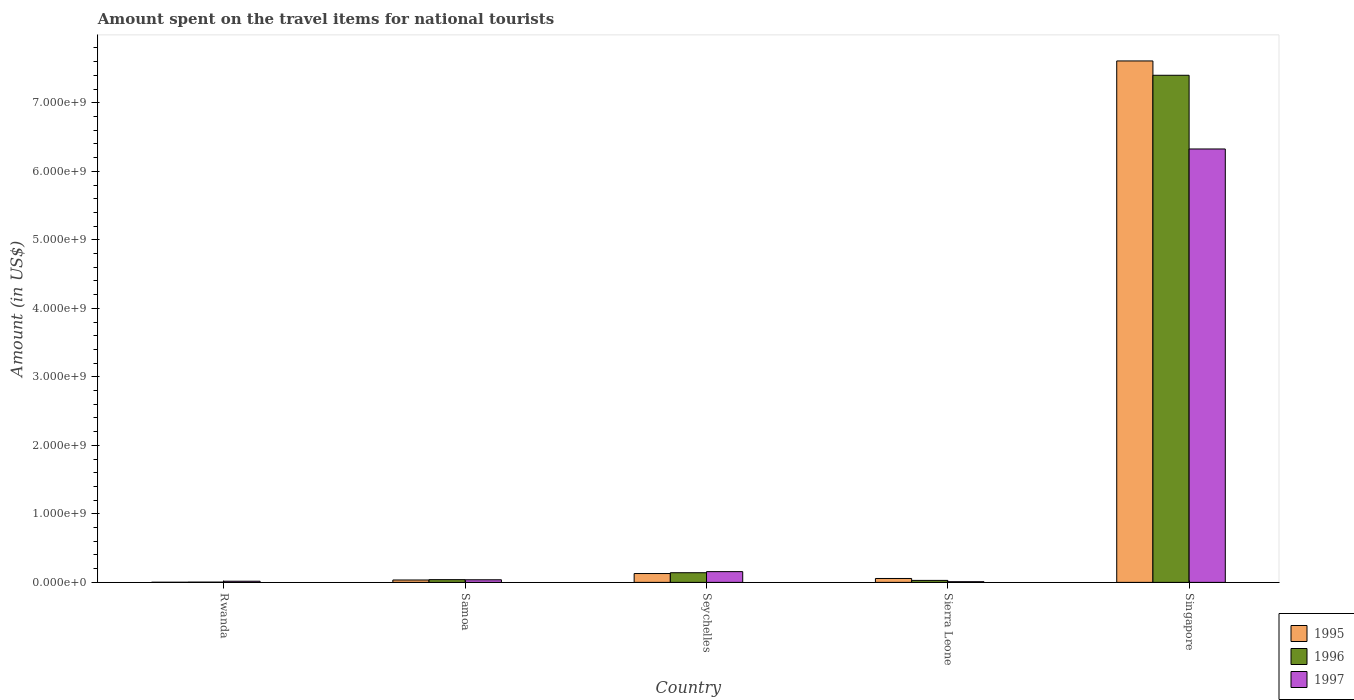How many different coloured bars are there?
Your answer should be very brief. 3. How many groups of bars are there?
Make the answer very short. 5. What is the label of the 4th group of bars from the left?
Provide a short and direct response. Sierra Leone. In how many cases, is the number of bars for a given country not equal to the number of legend labels?
Your response must be concise. 0. What is the amount spent on the travel items for national tourists in 1996 in Sierra Leone?
Make the answer very short. 2.90e+07. Across all countries, what is the maximum amount spent on the travel items for national tourists in 1995?
Your response must be concise. 7.61e+09. In which country was the amount spent on the travel items for national tourists in 1996 maximum?
Ensure brevity in your answer.  Singapore. In which country was the amount spent on the travel items for national tourists in 1996 minimum?
Your response must be concise. Rwanda. What is the total amount spent on the travel items for national tourists in 1995 in the graph?
Your answer should be compact. 7.83e+09. What is the difference between the amount spent on the travel items for national tourists in 1997 in Rwanda and that in Samoa?
Offer a terse response. -2.10e+07. What is the difference between the amount spent on the travel items for national tourists in 1995 in Seychelles and the amount spent on the travel items for national tourists in 1997 in Samoa?
Keep it short and to the point. 9.10e+07. What is the average amount spent on the travel items for national tourists in 1997 per country?
Offer a very short reply. 1.31e+09. What is the difference between the amount spent on the travel items for national tourists of/in 1996 and amount spent on the travel items for national tourists of/in 1995 in Samoa?
Provide a short and direct response. 5.00e+06. What is the ratio of the amount spent on the travel items for national tourists in 1995 in Samoa to that in Sierra Leone?
Ensure brevity in your answer.  0.61. Is the amount spent on the travel items for national tourists in 1995 in Seychelles less than that in Sierra Leone?
Offer a very short reply. No. What is the difference between the highest and the second highest amount spent on the travel items for national tourists in 1996?
Your response must be concise. 7.36e+09. What is the difference between the highest and the lowest amount spent on the travel items for national tourists in 1997?
Keep it short and to the point. 6.32e+09. What does the 2nd bar from the left in Seychelles represents?
Your answer should be compact. 1996. What does the 3rd bar from the right in Seychelles represents?
Ensure brevity in your answer.  1995. Is it the case that in every country, the sum of the amount spent on the travel items for national tourists in 1997 and amount spent on the travel items for national tourists in 1995 is greater than the amount spent on the travel items for national tourists in 1996?
Offer a very short reply. Yes. How many countries are there in the graph?
Your answer should be very brief. 5. What is the difference between two consecutive major ticks on the Y-axis?
Provide a short and direct response. 1.00e+09. Are the values on the major ticks of Y-axis written in scientific E-notation?
Provide a short and direct response. Yes. Does the graph contain any zero values?
Your answer should be compact. No. How many legend labels are there?
Make the answer very short. 3. How are the legend labels stacked?
Your response must be concise. Vertical. What is the title of the graph?
Offer a very short reply. Amount spent on the travel items for national tourists. What is the label or title of the X-axis?
Ensure brevity in your answer.  Country. What is the label or title of the Y-axis?
Your answer should be very brief. Amount (in US$). What is the Amount (in US$) in 1997 in Rwanda?
Your answer should be compact. 1.70e+07. What is the Amount (in US$) of 1995 in Samoa?
Your answer should be very brief. 3.50e+07. What is the Amount (in US$) in 1996 in Samoa?
Your answer should be compact. 4.00e+07. What is the Amount (in US$) of 1997 in Samoa?
Offer a terse response. 3.80e+07. What is the Amount (in US$) in 1995 in Seychelles?
Offer a very short reply. 1.29e+08. What is the Amount (in US$) in 1996 in Seychelles?
Your response must be concise. 1.41e+08. What is the Amount (in US$) in 1997 in Seychelles?
Ensure brevity in your answer.  1.57e+08. What is the Amount (in US$) of 1995 in Sierra Leone?
Offer a very short reply. 5.70e+07. What is the Amount (in US$) of 1996 in Sierra Leone?
Offer a terse response. 2.90e+07. What is the Amount (in US$) of 1995 in Singapore?
Provide a succinct answer. 7.61e+09. What is the Amount (in US$) of 1996 in Singapore?
Offer a terse response. 7.40e+09. What is the Amount (in US$) in 1997 in Singapore?
Keep it short and to the point. 6.33e+09. Across all countries, what is the maximum Amount (in US$) in 1995?
Your answer should be very brief. 7.61e+09. Across all countries, what is the maximum Amount (in US$) in 1996?
Your answer should be compact. 7.40e+09. Across all countries, what is the maximum Amount (in US$) in 1997?
Offer a very short reply. 6.33e+09. Across all countries, what is the minimum Amount (in US$) in 1995?
Provide a succinct answer. 2.00e+06. What is the total Amount (in US$) of 1995 in the graph?
Keep it short and to the point. 7.83e+09. What is the total Amount (in US$) of 1996 in the graph?
Make the answer very short. 7.62e+09. What is the total Amount (in US$) of 1997 in the graph?
Your answer should be compact. 6.55e+09. What is the difference between the Amount (in US$) of 1995 in Rwanda and that in Samoa?
Ensure brevity in your answer.  -3.30e+07. What is the difference between the Amount (in US$) in 1996 in Rwanda and that in Samoa?
Give a very brief answer. -3.60e+07. What is the difference between the Amount (in US$) of 1997 in Rwanda and that in Samoa?
Your response must be concise. -2.10e+07. What is the difference between the Amount (in US$) of 1995 in Rwanda and that in Seychelles?
Ensure brevity in your answer.  -1.27e+08. What is the difference between the Amount (in US$) of 1996 in Rwanda and that in Seychelles?
Ensure brevity in your answer.  -1.37e+08. What is the difference between the Amount (in US$) in 1997 in Rwanda and that in Seychelles?
Provide a succinct answer. -1.40e+08. What is the difference between the Amount (in US$) of 1995 in Rwanda and that in Sierra Leone?
Your answer should be very brief. -5.50e+07. What is the difference between the Amount (in US$) of 1996 in Rwanda and that in Sierra Leone?
Provide a short and direct response. -2.50e+07. What is the difference between the Amount (in US$) of 1995 in Rwanda and that in Singapore?
Your response must be concise. -7.61e+09. What is the difference between the Amount (in US$) of 1996 in Rwanda and that in Singapore?
Provide a succinct answer. -7.40e+09. What is the difference between the Amount (in US$) of 1997 in Rwanda and that in Singapore?
Offer a very short reply. -6.31e+09. What is the difference between the Amount (in US$) in 1995 in Samoa and that in Seychelles?
Give a very brief answer. -9.40e+07. What is the difference between the Amount (in US$) of 1996 in Samoa and that in Seychelles?
Your answer should be compact. -1.01e+08. What is the difference between the Amount (in US$) in 1997 in Samoa and that in Seychelles?
Your answer should be compact. -1.19e+08. What is the difference between the Amount (in US$) of 1995 in Samoa and that in Sierra Leone?
Provide a short and direct response. -2.20e+07. What is the difference between the Amount (in US$) of 1996 in Samoa and that in Sierra Leone?
Offer a terse response. 1.10e+07. What is the difference between the Amount (in US$) in 1997 in Samoa and that in Sierra Leone?
Offer a terse response. 2.80e+07. What is the difference between the Amount (in US$) in 1995 in Samoa and that in Singapore?
Your response must be concise. -7.58e+09. What is the difference between the Amount (in US$) in 1996 in Samoa and that in Singapore?
Make the answer very short. -7.36e+09. What is the difference between the Amount (in US$) of 1997 in Samoa and that in Singapore?
Provide a succinct answer. -6.29e+09. What is the difference between the Amount (in US$) of 1995 in Seychelles and that in Sierra Leone?
Provide a succinct answer. 7.20e+07. What is the difference between the Amount (in US$) in 1996 in Seychelles and that in Sierra Leone?
Provide a succinct answer. 1.12e+08. What is the difference between the Amount (in US$) in 1997 in Seychelles and that in Sierra Leone?
Keep it short and to the point. 1.47e+08. What is the difference between the Amount (in US$) in 1995 in Seychelles and that in Singapore?
Offer a very short reply. -7.48e+09. What is the difference between the Amount (in US$) of 1996 in Seychelles and that in Singapore?
Provide a short and direct response. -7.26e+09. What is the difference between the Amount (in US$) in 1997 in Seychelles and that in Singapore?
Your answer should be very brief. -6.17e+09. What is the difference between the Amount (in US$) of 1995 in Sierra Leone and that in Singapore?
Ensure brevity in your answer.  -7.55e+09. What is the difference between the Amount (in US$) of 1996 in Sierra Leone and that in Singapore?
Offer a very short reply. -7.37e+09. What is the difference between the Amount (in US$) in 1997 in Sierra Leone and that in Singapore?
Your answer should be compact. -6.32e+09. What is the difference between the Amount (in US$) in 1995 in Rwanda and the Amount (in US$) in 1996 in Samoa?
Give a very brief answer. -3.80e+07. What is the difference between the Amount (in US$) of 1995 in Rwanda and the Amount (in US$) of 1997 in Samoa?
Give a very brief answer. -3.60e+07. What is the difference between the Amount (in US$) of 1996 in Rwanda and the Amount (in US$) of 1997 in Samoa?
Your response must be concise. -3.40e+07. What is the difference between the Amount (in US$) of 1995 in Rwanda and the Amount (in US$) of 1996 in Seychelles?
Your answer should be very brief. -1.39e+08. What is the difference between the Amount (in US$) of 1995 in Rwanda and the Amount (in US$) of 1997 in Seychelles?
Keep it short and to the point. -1.55e+08. What is the difference between the Amount (in US$) in 1996 in Rwanda and the Amount (in US$) in 1997 in Seychelles?
Offer a terse response. -1.53e+08. What is the difference between the Amount (in US$) in 1995 in Rwanda and the Amount (in US$) in 1996 in Sierra Leone?
Offer a very short reply. -2.70e+07. What is the difference between the Amount (in US$) in 1995 in Rwanda and the Amount (in US$) in 1997 in Sierra Leone?
Provide a succinct answer. -8.00e+06. What is the difference between the Amount (in US$) in 1996 in Rwanda and the Amount (in US$) in 1997 in Sierra Leone?
Give a very brief answer. -6.00e+06. What is the difference between the Amount (in US$) in 1995 in Rwanda and the Amount (in US$) in 1996 in Singapore?
Give a very brief answer. -7.40e+09. What is the difference between the Amount (in US$) in 1995 in Rwanda and the Amount (in US$) in 1997 in Singapore?
Provide a succinct answer. -6.32e+09. What is the difference between the Amount (in US$) of 1996 in Rwanda and the Amount (in US$) of 1997 in Singapore?
Keep it short and to the point. -6.32e+09. What is the difference between the Amount (in US$) in 1995 in Samoa and the Amount (in US$) in 1996 in Seychelles?
Offer a very short reply. -1.06e+08. What is the difference between the Amount (in US$) in 1995 in Samoa and the Amount (in US$) in 1997 in Seychelles?
Make the answer very short. -1.22e+08. What is the difference between the Amount (in US$) in 1996 in Samoa and the Amount (in US$) in 1997 in Seychelles?
Offer a terse response. -1.17e+08. What is the difference between the Amount (in US$) in 1995 in Samoa and the Amount (in US$) in 1996 in Sierra Leone?
Offer a terse response. 6.00e+06. What is the difference between the Amount (in US$) of 1995 in Samoa and the Amount (in US$) of 1997 in Sierra Leone?
Provide a succinct answer. 2.50e+07. What is the difference between the Amount (in US$) in 1996 in Samoa and the Amount (in US$) in 1997 in Sierra Leone?
Provide a succinct answer. 3.00e+07. What is the difference between the Amount (in US$) in 1995 in Samoa and the Amount (in US$) in 1996 in Singapore?
Provide a succinct answer. -7.37e+09. What is the difference between the Amount (in US$) in 1995 in Samoa and the Amount (in US$) in 1997 in Singapore?
Your answer should be very brief. -6.29e+09. What is the difference between the Amount (in US$) of 1996 in Samoa and the Amount (in US$) of 1997 in Singapore?
Your answer should be very brief. -6.29e+09. What is the difference between the Amount (in US$) in 1995 in Seychelles and the Amount (in US$) in 1996 in Sierra Leone?
Your response must be concise. 1.00e+08. What is the difference between the Amount (in US$) of 1995 in Seychelles and the Amount (in US$) of 1997 in Sierra Leone?
Provide a succinct answer. 1.19e+08. What is the difference between the Amount (in US$) in 1996 in Seychelles and the Amount (in US$) in 1997 in Sierra Leone?
Give a very brief answer. 1.31e+08. What is the difference between the Amount (in US$) in 1995 in Seychelles and the Amount (in US$) in 1996 in Singapore?
Keep it short and to the point. -7.27e+09. What is the difference between the Amount (in US$) of 1995 in Seychelles and the Amount (in US$) of 1997 in Singapore?
Make the answer very short. -6.20e+09. What is the difference between the Amount (in US$) of 1996 in Seychelles and the Amount (in US$) of 1997 in Singapore?
Your answer should be very brief. -6.18e+09. What is the difference between the Amount (in US$) of 1995 in Sierra Leone and the Amount (in US$) of 1996 in Singapore?
Provide a succinct answer. -7.34e+09. What is the difference between the Amount (in US$) in 1995 in Sierra Leone and the Amount (in US$) in 1997 in Singapore?
Make the answer very short. -6.27e+09. What is the difference between the Amount (in US$) in 1996 in Sierra Leone and the Amount (in US$) in 1997 in Singapore?
Your answer should be very brief. -6.30e+09. What is the average Amount (in US$) in 1995 per country?
Your response must be concise. 1.57e+09. What is the average Amount (in US$) of 1996 per country?
Give a very brief answer. 1.52e+09. What is the average Amount (in US$) in 1997 per country?
Your answer should be compact. 1.31e+09. What is the difference between the Amount (in US$) in 1995 and Amount (in US$) in 1996 in Rwanda?
Provide a succinct answer. -2.00e+06. What is the difference between the Amount (in US$) of 1995 and Amount (in US$) of 1997 in Rwanda?
Your response must be concise. -1.50e+07. What is the difference between the Amount (in US$) of 1996 and Amount (in US$) of 1997 in Rwanda?
Your response must be concise. -1.30e+07. What is the difference between the Amount (in US$) of 1995 and Amount (in US$) of 1996 in Samoa?
Ensure brevity in your answer.  -5.00e+06. What is the difference between the Amount (in US$) in 1995 and Amount (in US$) in 1996 in Seychelles?
Offer a terse response. -1.20e+07. What is the difference between the Amount (in US$) of 1995 and Amount (in US$) of 1997 in Seychelles?
Ensure brevity in your answer.  -2.80e+07. What is the difference between the Amount (in US$) of 1996 and Amount (in US$) of 1997 in Seychelles?
Keep it short and to the point. -1.60e+07. What is the difference between the Amount (in US$) in 1995 and Amount (in US$) in 1996 in Sierra Leone?
Provide a succinct answer. 2.80e+07. What is the difference between the Amount (in US$) of 1995 and Amount (in US$) of 1997 in Sierra Leone?
Ensure brevity in your answer.  4.70e+07. What is the difference between the Amount (in US$) in 1996 and Amount (in US$) in 1997 in Sierra Leone?
Provide a succinct answer. 1.90e+07. What is the difference between the Amount (in US$) in 1995 and Amount (in US$) in 1996 in Singapore?
Offer a very short reply. 2.09e+08. What is the difference between the Amount (in US$) in 1995 and Amount (in US$) in 1997 in Singapore?
Your response must be concise. 1.28e+09. What is the difference between the Amount (in US$) of 1996 and Amount (in US$) of 1997 in Singapore?
Your answer should be very brief. 1.08e+09. What is the ratio of the Amount (in US$) in 1995 in Rwanda to that in Samoa?
Your response must be concise. 0.06. What is the ratio of the Amount (in US$) of 1996 in Rwanda to that in Samoa?
Offer a terse response. 0.1. What is the ratio of the Amount (in US$) of 1997 in Rwanda to that in Samoa?
Offer a terse response. 0.45. What is the ratio of the Amount (in US$) of 1995 in Rwanda to that in Seychelles?
Your response must be concise. 0.02. What is the ratio of the Amount (in US$) in 1996 in Rwanda to that in Seychelles?
Offer a terse response. 0.03. What is the ratio of the Amount (in US$) in 1997 in Rwanda to that in Seychelles?
Provide a short and direct response. 0.11. What is the ratio of the Amount (in US$) in 1995 in Rwanda to that in Sierra Leone?
Give a very brief answer. 0.04. What is the ratio of the Amount (in US$) of 1996 in Rwanda to that in Sierra Leone?
Offer a terse response. 0.14. What is the ratio of the Amount (in US$) in 1996 in Rwanda to that in Singapore?
Give a very brief answer. 0. What is the ratio of the Amount (in US$) in 1997 in Rwanda to that in Singapore?
Provide a succinct answer. 0. What is the ratio of the Amount (in US$) in 1995 in Samoa to that in Seychelles?
Offer a very short reply. 0.27. What is the ratio of the Amount (in US$) of 1996 in Samoa to that in Seychelles?
Keep it short and to the point. 0.28. What is the ratio of the Amount (in US$) in 1997 in Samoa to that in Seychelles?
Ensure brevity in your answer.  0.24. What is the ratio of the Amount (in US$) in 1995 in Samoa to that in Sierra Leone?
Keep it short and to the point. 0.61. What is the ratio of the Amount (in US$) of 1996 in Samoa to that in Sierra Leone?
Provide a short and direct response. 1.38. What is the ratio of the Amount (in US$) in 1995 in Samoa to that in Singapore?
Ensure brevity in your answer.  0. What is the ratio of the Amount (in US$) in 1996 in Samoa to that in Singapore?
Keep it short and to the point. 0.01. What is the ratio of the Amount (in US$) in 1997 in Samoa to that in Singapore?
Keep it short and to the point. 0.01. What is the ratio of the Amount (in US$) in 1995 in Seychelles to that in Sierra Leone?
Keep it short and to the point. 2.26. What is the ratio of the Amount (in US$) in 1996 in Seychelles to that in Sierra Leone?
Give a very brief answer. 4.86. What is the ratio of the Amount (in US$) of 1995 in Seychelles to that in Singapore?
Keep it short and to the point. 0.02. What is the ratio of the Amount (in US$) of 1996 in Seychelles to that in Singapore?
Offer a very short reply. 0.02. What is the ratio of the Amount (in US$) in 1997 in Seychelles to that in Singapore?
Ensure brevity in your answer.  0.02. What is the ratio of the Amount (in US$) of 1995 in Sierra Leone to that in Singapore?
Give a very brief answer. 0.01. What is the ratio of the Amount (in US$) in 1996 in Sierra Leone to that in Singapore?
Ensure brevity in your answer.  0. What is the ratio of the Amount (in US$) in 1997 in Sierra Leone to that in Singapore?
Offer a very short reply. 0. What is the difference between the highest and the second highest Amount (in US$) of 1995?
Your answer should be compact. 7.48e+09. What is the difference between the highest and the second highest Amount (in US$) in 1996?
Your response must be concise. 7.26e+09. What is the difference between the highest and the second highest Amount (in US$) in 1997?
Give a very brief answer. 6.17e+09. What is the difference between the highest and the lowest Amount (in US$) of 1995?
Offer a very short reply. 7.61e+09. What is the difference between the highest and the lowest Amount (in US$) in 1996?
Offer a terse response. 7.40e+09. What is the difference between the highest and the lowest Amount (in US$) in 1997?
Your response must be concise. 6.32e+09. 